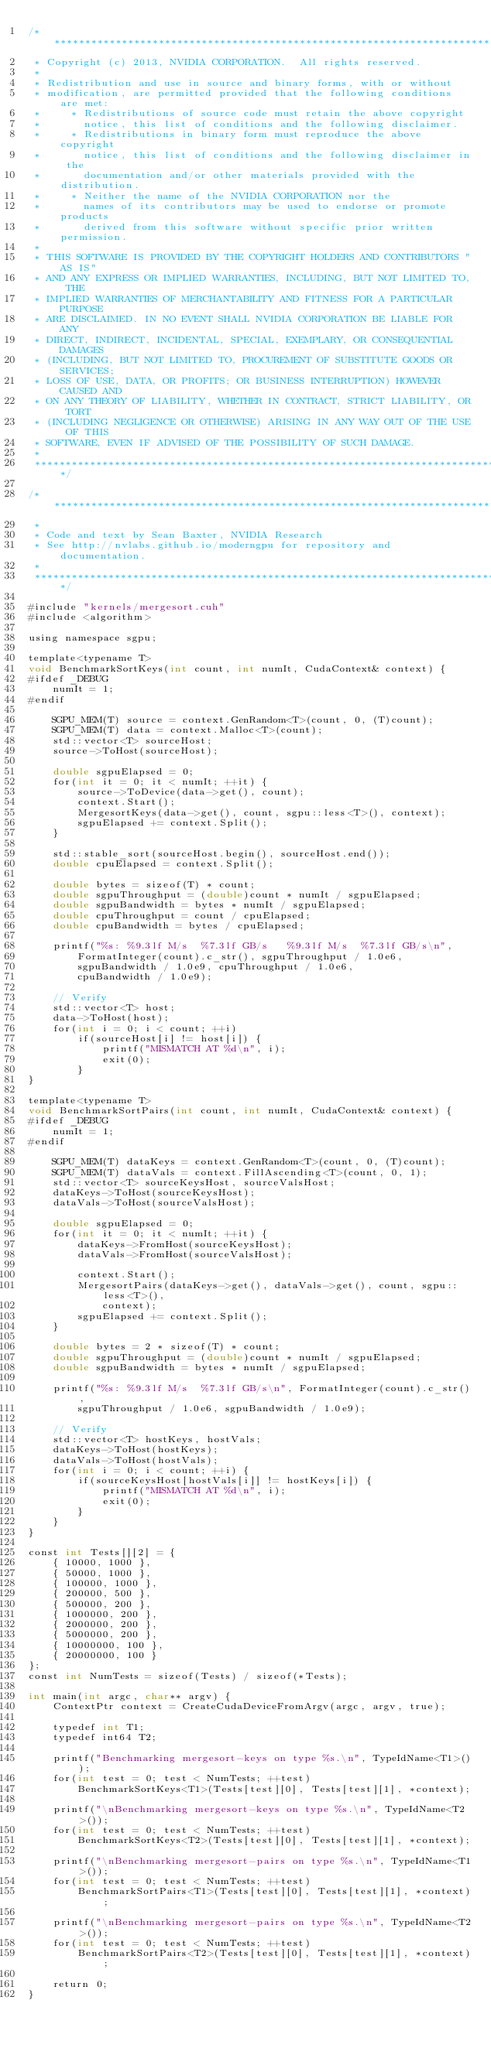Convert code to text. <code><loc_0><loc_0><loc_500><loc_500><_Cuda_>/******************************************************************************
 * Copyright (c) 2013, NVIDIA CORPORATION.  All rights reserved.
 *
 * Redistribution and use in source and binary forms, with or without
 * modification, are permitted provided that the following conditions are met:
 *     * Redistributions of source code must retain the above copyright
 *       notice, this list of conditions and the following disclaimer.
 *     * Redistributions in binary form must reproduce the above copyright
 *       notice, this list of conditions and the following disclaimer in the
 *       documentation and/or other materials provided with the distribution.
 *     * Neither the name of the NVIDIA CORPORATION nor the
 *       names of its contributors may be used to endorse or promote products
 *       derived from this software without specific prior written permission.
 *
 * THIS SOFTWARE IS PROVIDED BY THE COPYRIGHT HOLDERS AND CONTRIBUTORS "AS IS"
 * AND ANY EXPRESS OR IMPLIED WARRANTIES, INCLUDING, BUT NOT LIMITED TO, THE
 * IMPLIED WARRANTIES OF MERCHANTABILITY AND FITNESS FOR A PARTICULAR PURPOSE
 * ARE DISCLAIMED. IN NO EVENT SHALL NVIDIA CORPORATION BE LIABLE FOR ANY
 * DIRECT, INDIRECT, INCIDENTAL, SPECIAL, EXEMPLARY, OR CONSEQUENTIAL DAMAGES
 * (INCLUDING, BUT NOT LIMITED TO, PROCUREMENT OF SUBSTITUTE GOODS OR SERVICES;
 * LOSS OF USE, DATA, OR PROFITS; OR BUSINESS INTERRUPTION) HOWEVER CAUSED AND
 * ON ANY THEORY OF LIABILITY, WHETHER IN CONTRACT, STRICT LIABILITY, OR TORT
 * (INCLUDING NEGLIGENCE OR OTHERWISE) ARISING IN ANY WAY OUT OF THE USE OF THIS
 * SOFTWARE, EVEN IF ADVISED OF THE POSSIBILITY OF SUCH DAMAGE.
 *
 ******************************************************************************/

/******************************************************************************
 *
 * Code and text by Sean Baxter, NVIDIA Research
 * See http://nvlabs.github.io/moderngpu for repository and documentation.
 *
 ******************************************************************************/

#include "kernels/mergesort.cuh"
#include <algorithm>

using namespace sgpu;

template<typename T>
void BenchmarkSortKeys(int count, int numIt, CudaContext& context) {
#ifdef _DEBUG
	numIt = 1;
#endif

	SGPU_MEM(T) source = context.GenRandom<T>(count, 0, (T)count);
	SGPU_MEM(T) data = context.Malloc<T>(count);
	std::vector<T> sourceHost;
	source->ToHost(sourceHost);

	double sgpuElapsed = 0;
	for(int it = 0; it < numIt; ++it) {
		source->ToDevice(data->get(), count);
		context.Start();
		MergesortKeys(data->get(), count, sgpu::less<T>(), context);
		sgpuElapsed += context.Split();
	}

	std::stable_sort(sourceHost.begin(), sourceHost.end());
	double cpuElapsed = context.Split();

	double bytes = sizeof(T) * count;
	double sgpuThroughput = (double)count * numIt / sgpuElapsed;
	double sgpuBandwidth = bytes * numIt / sgpuElapsed;
	double cpuThroughput = count / cpuElapsed;
	double cpuBandwidth = bytes / cpuElapsed;

	printf("%s: %9.3lf M/s  %7.3lf GB/s   %9.3lf M/s  %7.3lf GB/s\n",
		FormatInteger(count).c_str(), sgpuThroughput / 1.0e6,
		sgpuBandwidth / 1.0e9, cpuThroughput / 1.0e6,
		cpuBandwidth / 1.0e9);

	// Verify
	std::vector<T> host;
	data->ToHost(host);
	for(int i = 0; i < count; ++i)
		if(sourceHost[i] != host[i]) {
			printf("MISMATCH AT %d\n", i);
			exit(0);
		}
}

template<typename T>
void BenchmarkSortPairs(int count, int numIt, CudaContext& context) {
#ifdef _DEBUG
	numIt = 1;
#endif

	SGPU_MEM(T) dataKeys = context.GenRandom<T>(count, 0, (T)count);
	SGPU_MEM(T) dataVals = context.FillAscending<T>(count, 0, 1);
	std::vector<T> sourceKeysHost, sourceValsHost;
	dataKeys->ToHost(sourceKeysHost);
	dataVals->ToHost(sourceValsHost);

	double sgpuElapsed = 0;
	for(int it = 0; it < numIt; ++it) {
		dataKeys->FromHost(sourceKeysHost);
		dataVals->FromHost(sourceValsHost);

		context.Start();
		MergesortPairs(dataKeys->get(), dataVals->get(), count, sgpu::less<T>(),
			context);
		sgpuElapsed += context.Split();
	}

	double bytes = 2 * sizeof(T) * count;
	double sgpuThroughput = (double)count * numIt / sgpuElapsed;
	double sgpuBandwidth = bytes * numIt / sgpuElapsed;

	printf("%s: %9.3lf M/s  %7.3lf GB/s\n", FormatInteger(count).c_str(),
		sgpuThroughput / 1.0e6, sgpuBandwidth / 1.0e9);

	// Verify
	std::vector<T> hostKeys, hostVals;
	dataKeys->ToHost(hostKeys);
	dataVals->ToHost(hostVals);
	for(int i = 0; i < count; ++i) {
		if(sourceKeysHost[hostVals[i]] != hostKeys[i]) {
			printf("MISMATCH AT %d\n", i);
			exit(0);
		}
	}
}

const int Tests[][2] = {
	{ 10000, 1000 },
	{ 50000, 1000 },
	{ 100000, 1000 },
	{ 200000, 500 },
	{ 500000, 200 },
	{ 1000000, 200 },
	{ 2000000, 200 },
	{ 5000000, 200 },
	{ 10000000, 100 },
	{ 20000000, 100 }
};
const int NumTests = sizeof(Tests) / sizeof(*Tests);

int main(int argc, char** argv) {
	ContextPtr context = CreateCudaDeviceFromArgv(argc, argv, true);

	typedef int T1;
	typedef int64 T2;

	printf("Benchmarking mergesort-keys on type %s.\n", TypeIdName<T1>());
	for(int test = 0; test < NumTests; ++test)
		BenchmarkSortKeys<T1>(Tests[test][0], Tests[test][1], *context);

	printf("\nBenchmarking mergesort-keys on type %s.\n", TypeIdName<T2>());
	for(int test = 0; test < NumTests; ++test)
		BenchmarkSortKeys<T2>(Tests[test][0], Tests[test][1], *context);

	printf("\nBenchmarking mergesort-pairs on type %s.\n", TypeIdName<T1>());
	for(int test = 0; test < NumTests; ++test)
		BenchmarkSortPairs<T1>(Tests[test][0], Tests[test][1], *context);

	printf("\nBenchmarking mergesort-pairs on type %s.\n", TypeIdName<T2>());
	for(int test = 0; test < NumTests; ++test)
		BenchmarkSortPairs<T2>(Tests[test][0], Tests[test][1], *context);

	return 0;
}
</code> 